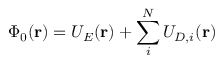Convert formula to latex. <formula><loc_0><loc_0><loc_500><loc_500>\Phi _ { 0 } ( r ) = U _ { E } ( r ) + \sum _ { i } ^ { N } U _ { D , i } ( r )</formula> 